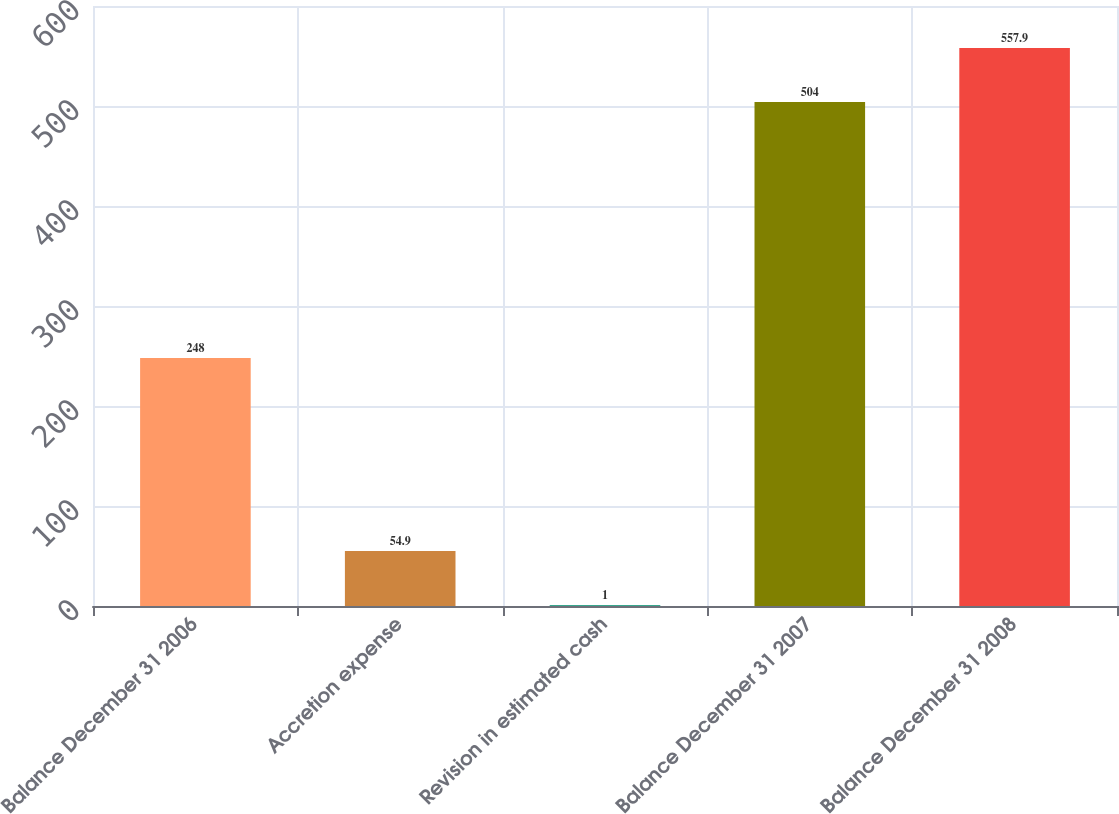<chart> <loc_0><loc_0><loc_500><loc_500><bar_chart><fcel>Balance December 31 2006<fcel>Accretion expense<fcel>Revision in estimated cash<fcel>Balance December 31 2007<fcel>Balance December 31 2008<nl><fcel>248<fcel>54.9<fcel>1<fcel>504<fcel>557.9<nl></chart> 